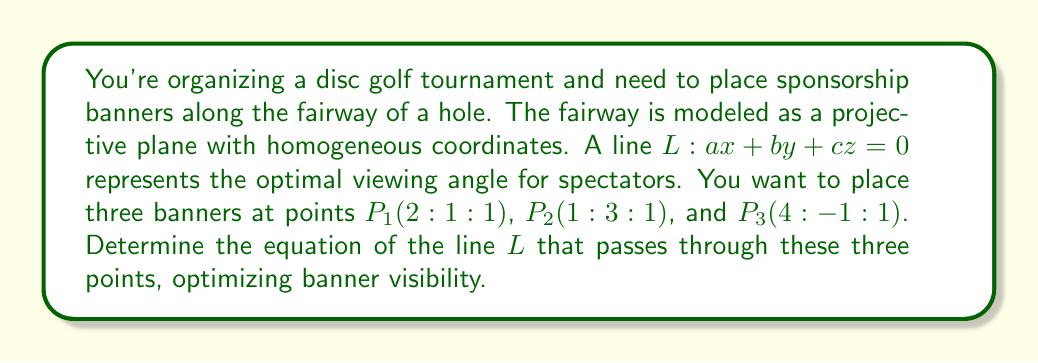Provide a solution to this math problem. To solve this problem, we'll use concepts from projective geometry:

1) In projective geometry, three points are collinear if and only if their determinant is zero. We can use this to find the equation of the line passing through the three points.

2) Let's set up the determinant using the coordinates of the three points and the general equation of a line $(ax + by + cz = 0)$:

   $$\begin{vmatrix} 
   2 & 1 & 1 & a \\
   1 & 3 & 1 & b \\
   4 & -1 & 1 & c \\
   x & y & z & 0
   \end{vmatrix} = 0$$

3) Expanding this determinant (using Laplace expansion along the last row):

   $$x\begin{vmatrix} 
   1 & 1 & a \\
   3 & 1 & b \\
   -1 & 1 & c
   \end{vmatrix} - y\begin{vmatrix} 
   2 & 1 & a \\
   1 & 1 & b \\
   4 & 1 & c
   \end{vmatrix} + z\begin{vmatrix} 
   2 & 1 & a \\
   1 & 3 & b \\
   4 & -1 & c
   \end{vmatrix} = 0$$

4) Calculating these 3x3 determinants:

   $$x(c - 4a + 3b) - y(-3c + 3a - b) + z(10a - 6b - c) = 0$$

5) Simplifying:

   $$(c - 4a + 3b)x + (3c - 3a + b)y + (10a - 6b - c)z = 0$$

6) This is the equation of the line $L$ in the form $ax + by + cz = 0$. We can simplify by setting $c = 1$ (since projective coordinates are defined up to a scalar multiple):

   $$(1 - 4a + 3b)x + (3 - 3a + b)y + (10a - 6b - 1)z = 0$$

7) Comparing coefficients with the general form $ax + by + cz = 0$:

   $a = 1 - 4a + 3b$
   $b = 3 - 3a + b$
   $c = 10a - 6b - 1$

8) Solving this system of equations:

   $a = \frac{5}{13}$, $b = \frac{7}{13}$, $c = 1$

Therefore, the equation of the line $L$ is $\frac{5}{13}x + \frac{7}{13}y + z = 0$.
Answer: $\frac{5}{13}x + \frac{7}{13}y + z = 0$ 